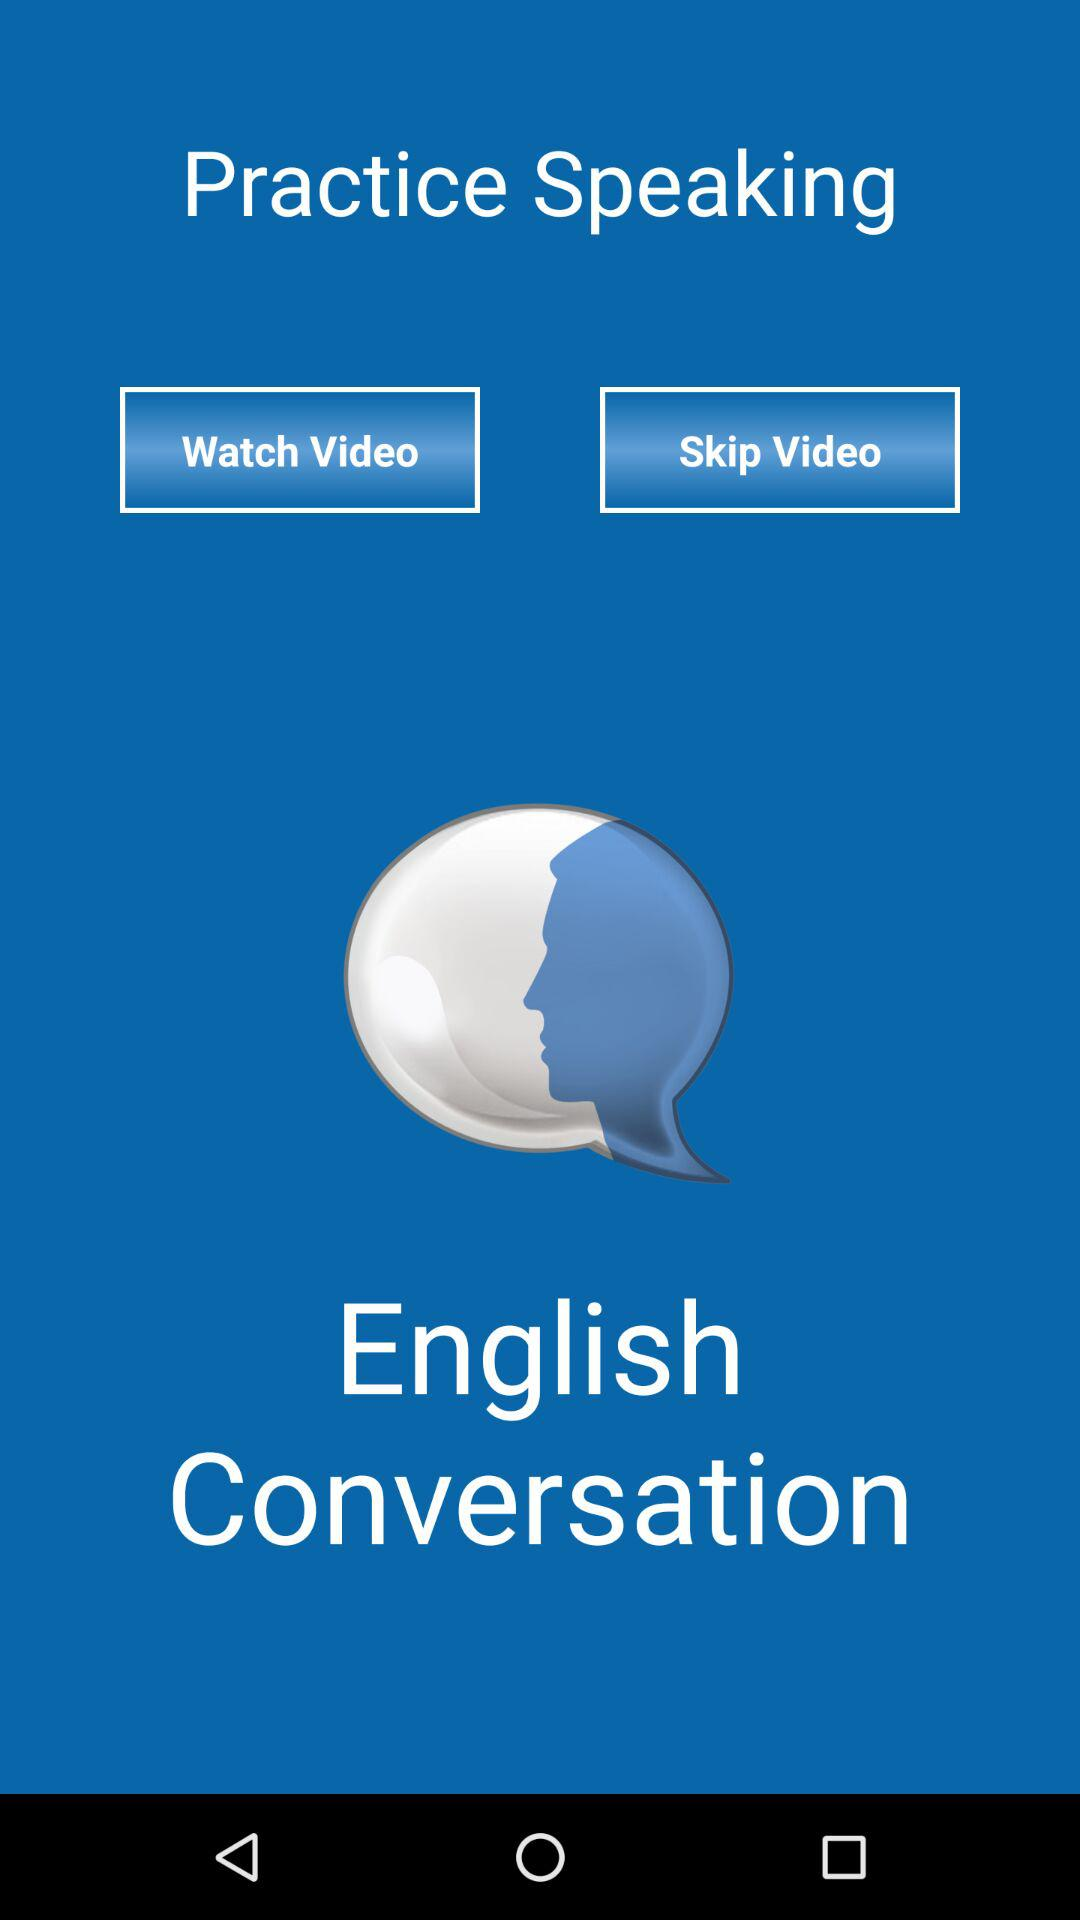What is the name of the application? The application name is "English Conversation". 